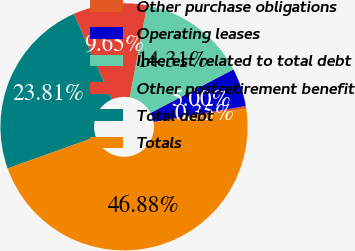<chart> <loc_0><loc_0><loc_500><loc_500><pie_chart><fcel>Other purchase obligations<fcel>Operating leases<fcel>Interest related to total debt<fcel>Other postretirement benefit<fcel>Total debt<fcel>Totals<nl><fcel>0.35%<fcel>5.0%<fcel>14.31%<fcel>9.65%<fcel>23.81%<fcel>46.88%<nl></chart> 